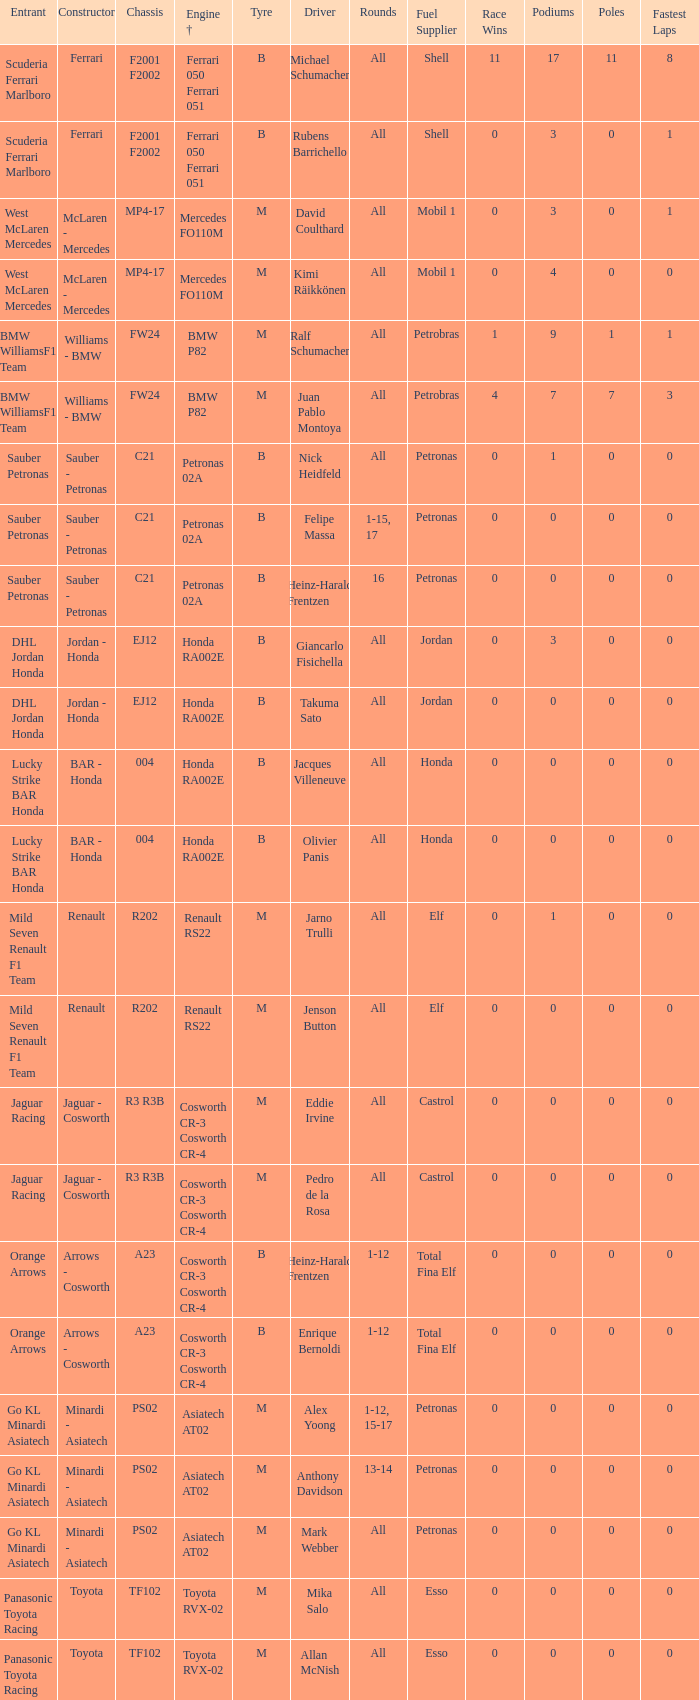Who is the driver when the engine is mercedes fo110m? David Coulthard, Kimi Räikkönen. 